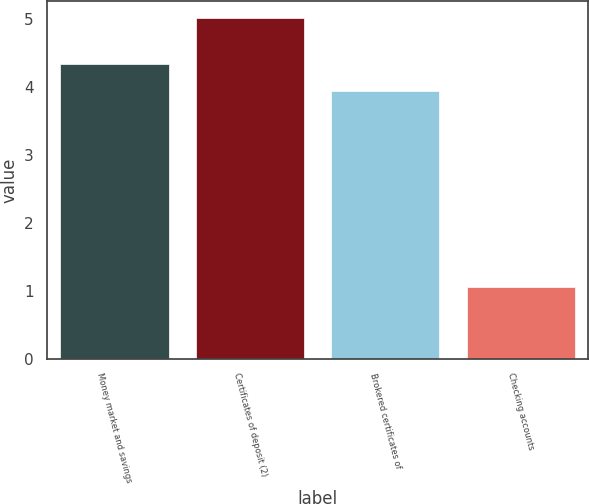<chart> <loc_0><loc_0><loc_500><loc_500><bar_chart><fcel>Money market and savings<fcel>Certificates of deposit (2)<fcel>Brokered certificates of<fcel>Checking accounts<nl><fcel>4.35<fcel>5.02<fcel>3.95<fcel>1.06<nl></chart> 